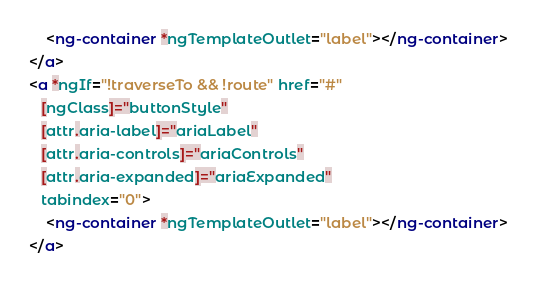Convert code to text. <code><loc_0><loc_0><loc_500><loc_500><_HTML_>    <ng-container *ngTemplateOutlet="label"></ng-container>
</a>
<a *ngIf="!traverseTo && !route" href="#"
   [ngClass]="buttonStyle"
   [attr.aria-label]="ariaLabel"
   [attr.aria-controls]="ariaControls"
   [attr.aria-expanded]="ariaExpanded"
   tabindex="0">
    <ng-container *ngTemplateOutlet="label"></ng-container>
</a></code> 